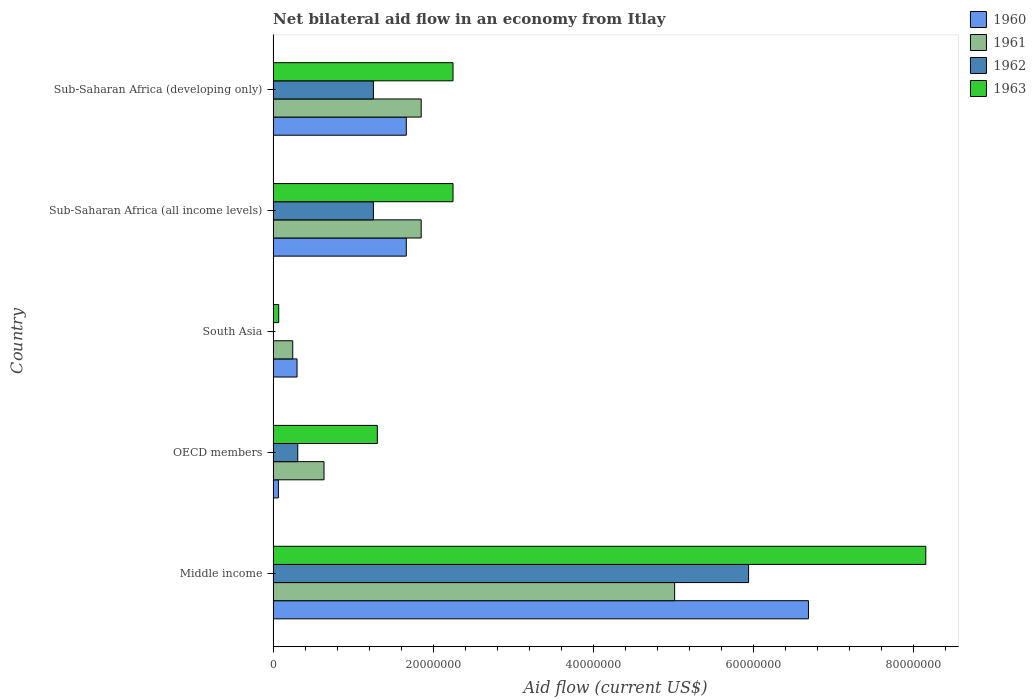How many groups of bars are there?
Your answer should be compact. 5. Are the number of bars per tick equal to the number of legend labels?
Offer a terse response. No. Are the number of bars on each tick of the Y-axis equal?
Your response must be concise. No. How many bars are there on the 5th tick from the top?
Give a very brief answer. 4. What is the label of the 1st group of bars from the top?
Keep it short and to the point. Sub-Saharan Africa (developing only). In how many cases, is the number of bars for a given country not equal to the number of legend labels?
Your response must be concise. 1. What is the net bilateral aid flow in 1961 in OECD members?
Provide a short and direct response. 6.36e+06. Across all countries, what is the maximum net bilateral aid flow in 1963?
Make the answer very short. 8.16e+07. Across all countries, what is the minimum net bilateral aid flow in 1961?
Keep it short and to the point. 2.45e+06. What is the total net bilateral aid flow in 1963 in the graph?
Give a very brief answer. 1.40e+08. What is the difference between the net bilateral aid flow in 1961 in OECD members and that in Sub-Saharan Africa (all income levels)?
Your answer should be compact. -1.21e+07. What is the difference between the net bilateral aid flow in 1961 in OECD members and the net bilateral aid flow in 1963 in Sub-Saharan Africa (developing only)?
Your answer should be compact. -1.61e+07. What is the average net bilateral aid flow in 1961 per country?
Offer a very short reply. 1.92e+07. What is the difference between the net bilateral aid flow in 1963 and net bilateral aid flow in 1960 in OECD members?
Your response must be concise. 1.24e+07. In how many countries, is the net bilateral aid flow in 1962 greater than 36000000 US$?
Give a very brief answer. 1. What is the ratio of the net bilateral aid flow in 1962 in Middle income to that in Sub-Saharan Africa (developing only)?
Provide a short and direct response. 4.74. What is the difference between the highest and the second highest net bilateral aid flow in 1963?
Your answer should be very brief. 5.91e+07. What is the difference between the highest and the lowest net bilateral aid flow in 1960?
Offer a very short reply. 6.62e+07. In how many countries, is the net bilateral aid flow in 1962 greater than the average net bilateral aid flow in 1962 taken over all countries?
Provide a succinct answer. 1. Is the sum of the net bilateral aid flow in 1961 in Middle income and OECD members greater than the maximum net bilateral aid flow in 1962 across all countries?
Make the answer very short. No. Is it the case that in every country, the sum of the net bilateral aid flow in 1962 and net bilateral aid flow in 1960 is greater than the sum of net bilateral aid flow in 1963 and net bilateral aid flow in 1961?
Offer a very short reply. No. How many countries are there in the graph?
Offer a very short reply. 5. Are the values on the major ticks of X-axis written in scientific E-notation?
Your answer should be compact. No. Does the graph contain grids?
Your answer should be very brief. No. What is the title of the graph?
Your answer should be very brief. Net bilateral aid flow in an economy from Itlay. What is the label or title of the X-axis?
Your response must be concise. Aid flow (current US$). What is the label or title of the Y-axis?
Ensure brevity in your answer.  Country. What is the Aid flow (current US$) in 1960 in Middle income?
Ensure brevity in your answer.  6.69e+07. What is the Aid flow (current US$) of 1961 in Middle income?
Your answer should be very brief. 5.02e+07. What is the Aid flow (current US$) of 1962 in Middle income?
Provide a succinct answer. 5.94e+07. What is the Aid flow (current US$) of 1963 in Middle income?
Provide a succinct answer. 8.16e+07. What is the Aid flow (current US$) in 1960 in OECD members?
Make the answer very short. 6.60e+05. What is the Aid flow (current US$) in 1961 in OECD members?
Ensure brevity in your answer.  6.36e+06. What is the Aid flow (current US$) in 1962 in OECD members?
Your response must be concise. 3.08e+06. What is the Aid flow (current US$) of 1963 in OECD members?
Offer a terse response. 1.30e+07. What is the Aid flow (current US$) of 1960 in South Asia?
Offer a terse response. 2.99e+06. What is the Aid flow (current US$) of 1961 in South Asia?
Provide a succinct answer. 2.45e+06. What is the Aid flow (current US$) of 1960 in Sub-Saharan Africa (all income levels)?
Offer a very short reply. 1.66e+07. What is the Aid flow (current US$) in 1961 in Sub-Saharan Africa (all income levels)?
Make the answer very short. 1.85e+07. What is the Aid flow (current US$) of 1962 in Sub-Saharan Africa (all income levels)?
Give a very brief answer. 1.25e+07. What is the Aid flow (current US$) of 1963 in Sub-Saharan Africa (all income levels)?
Your answer should be compact. 2.25e+07. What is the Aid flow (current US$) of 1960 in Sub-Saharan Africa (developing only)?
Keep it short and to the point. 1.66e+07. What is the Aid flow (current US$) in 1961 in Sub-Saharan Africa (developing only)?
Provide a succinct answer. 1.85e+07. What is the Aid flow (current US$) in 1962 in Sub-Saharan Africa (developing only)?
Make the answer very short. 1.25e+07. What is the Aid flow (current US$) of 1963 in Sub-Saharan Africa (developing only)?
Offer a very short reply. 2.25e+07. Across all countries, what is the maximum Aid flow (current US$) in 1960?
Provide a succinct answer. 6.69e+07. Across all countries, what is the maximum Aid flow (current US$) in 1961?
Offer a very short reply. 5.02e+07. Across all countries, what is the maximum Aid flow (current US$) in 1962?
Make the answer very short. 5.94e+07. Across all countries, what is the maximum Aid flow (current US$) in 1963?
Your answer should be compact. 8.16e+07. Across all countries, what is the minimum Aid flow (current US$) in 1960?
Provide a succinct answer. 6.60e+05. Across all countries, what is the minimum Aid flow (current US$) in 1961?
Keep it short and to the point. 2.45e+06. Across all countries, what is the minimum Aid flow (current US$) in 1963?
Keep it short and to the point. 7.00e+05. What is the total Aid flow (current US$) in 1960 in the graph?
Give a very brief answer. 1.04e+08. What is the total Aid flow (current US$) in 1961 in the graph?
Ensure brevity in your answer.  9.60e+07. What is the total Aid flow (current US$) of 1962 in the graph?
Your answer should be very brief. 8.76e+07. What is the total Aid flow (current US$) of 1963 in the graph?
Provide a short and direct response. 1.40e+08. What is the difference between the Aid flow (current US$) of 1960 in Middle income and that in OECD members?
Provide a short and direct response. 6.62e+07. What is the difference between the Aid flow (current US$) in 1961 in Middle income and that in OECD members?
Provide a short and direct response. 4.38e+07. What is the difference between the Aid flow (current US$) in 1962 in Middle income and that in OECD members?
Your answer should be very brief. 5.63e+07. What is the difference between the Aid flow (current US$) of 1963 in Middle income and that in OECD members?
Give a very brief answer. 6.85e+07. What is the difference between the Aid flow (current US$) in 1960 in Middle income and that in South Asia?
Provide a short and direct response. 6.39e+07. What is the difference between the Aid flow (current US$) in 1961 in Middle income and that in South Asia?
Ensure brevity in your answer.  4.77e+07. What is the difference between the Aid flow (current US$) of 1963 in Middle income and that in South Asia?
Your answer should be compact. 8.08e+07. What is the difference between the Aid flow (current US$) in 1960 in Middle income and that in Sub-Saharan Africa (all income levels)?
Your answer should be very brief. 5.02e+07. What is the difference between the Aid flow (current US$) of 1961 in Middle income and that in Sub-Saharan Africa (all income levels)?
Keep it short and to the point. 3.17e+07. What is the difference between the Aid flow (current US$) in 1962 in Middle income and that in Sub-Saharan Africa (all income levels)?
Offer a terse response. 4.69e+07. What is the difference between the Aid flow (current US$) of 1963 in Middle income and that in Sub-Saharan Africa (all income levels)?
Your answer should be very brief. 5.91e+07. What is the difference between the Aid flow (current US$) of 1960 in Middle income and that in Sub-Saharan Africa (developing only)?
Keep it short and to the point. 5.02e+07. What is the difference between the Aid flow (current US$) in 1961 in Middle income and that in Sub-Saharan Africa (developing only)?
Keep it short and to the point. 3.17e+07. What is the difference between the Aid flow (current US$) in 1962 in Middle income and that in Sub-Saharan Africa (developing only)?
Provide a short and direct response. 4.69e+07. What is the difference between the Aid flow (current US$) of 1963 in Middle income and that in Sub-Saharan Africa (developing only)?
Provide a short and direct response. 5.91e+07. What is the difference between the Aid flow (current US$) in 1960 in OECD members and that in South Asia?
Provide a succinct answer. -2.33e+06. What is the difference between the Aid flow (current US$) of 1961 in OECD members and that in South Asia?
Your answer should be compact. 3.91e+06. What is the difference between the Aid flow (current US$) of 1963 in OECD members and that in South Asia?
Your answer should be compact. 1.23e+07. What is the difference between the Aid flow (current US$) in 1960 in OECD members and that in Sub-Saharan Africa (all income levels)?
Your answer should be compact. -1.60e+07. What is the difference between the Aid flow (current US$) of 1961 in OECD members and that in Sub-Saharan Africa (all income levels)?
Your response must be concise. -1.21e+07. What is the difference between the Aid flow (current US$) in 1962 in OECD members and that in Sub-Saharan Africa (all income levels)?
Offer a very short reply. -9.45e+06. What is the difference between the Aid flow (current US$) of 1963 in OECD members and that in Sub-Saharan Africa (all income levels)?
Offer a very short reply. -9.46e+06. What is the difference between the Aid flow (current US$) in 1960 in OECD members and that in Sub-Saharan Africa (developing only)?
Provide a short and direct response. -1.60e+07. What is the difference between the Aid flow (current US$) in 1961 in OECD members and that in Sub-Saharan Africa (developing only)?
Your answer should be compact. -1.21e+07. What is the difference between the Aid flow (current US$) in 1962 in OECD members and that in Sub-Saharan Africa (developing only)?
Keep it short and to the point. -9.45e+06. What is the difference between the Aid flow (current US$) in 1963 in OECD members and that in Sub-Saharan Africa (developing only)?
Give a very brief answer. -9.46e+06. What is the difference between the Aid flow (current US$) of 1960 in South Asia and that in Sub-Saharan Africa (all income levels)?
Provide a succinct answer. -1.36e+07. What is the difference between the Aid flow (current US$) in 1961 in South Asia and that in Sub-Saharan Africa (all income levels)?
Your response must be concise. -1.60e+07. What is the difference between the Aid flow (current US$) in 1963 in South Asia and that in Sub-Saharan Africa (all income levels)?
Your answer should be compact. -2.18e+07. What is the difference between the Aid flow (current US$) in 1960 in South Asia and that in Sub-Saharan Africa (developing only)?
Your answer should be very brief. -1.36e+07. What is the difference between the Aid flow (current US$) in 1961 in South Asia and that in Sub-Saharan Africa (developing only)?
Provide a short and direct response. -1.60e+07. What is the difference between the Aid flow (current US$) in 1963 in South Asia and that in Sub-Saharan Africa (developing only)?
Make the answer very short. -2.18e+07. What is the difference between the Aid flow (current US$) in 1961 in Sub-Saharan Africa (all income levels) and that in Sub-Saharan Africa (developing only)?
Your answer should be compact. 0. What is the difference between the Aid flow (current US$) of 1962 in Sub-Saharan Africa (all income levels) and that in Sub-Saharan Africa (developing only)?
Provide a short and direct response. 0. What is the difference between the Aid flow (current US$) of 1960 in Middle income and the Aid flow (current US$) of 1961 in OECD members?
Make the answer very short. 6.05e+07. What is the difference between the Aid flow (current US$) of 1960 in Middle income and the Aid flow (current US$) of 1962 in OECD members?
Offer a terse response. 6.38e+07. What is the difference between the Aid flow (current US$) of 1960 in Middle income and the Aid flow (current US$) of 1963 in OECD members?
Provide a short and direct response. 5.39e+07. What is the difference between the Aid flow (current US$) of 1961 in Middle income and the Aid flow (current US$) of 1962 in OECD members?
Provide a short and direct response. 4.71e+07. What is the difference between the Aid flow (current US$) of 1961 in Middle income and the Aid flow (current US$) of 1963 in OECD members?
Keep it short and to the point. 3.72e+07. What is the difference between the Aid flow (current US$) of 1962 in Middle income and the Aid flow (current US$) of 1963 in OECD members?
Your answer should be very brief. 4.64e+07. What is the difference between the Aid flow (current US$) of 1960 in Middle income and the Aid flow (current US$) of 1961 in South Asia?
Ensure brevity in your answer.  6.44e+07. What is the difference between the Aid flow (current US$) in 1960 in Middle income and the Aid flow (current US$) in 1963 in South Asia?
Your answer should be very brief. 6.62e+07. What is the difference between the Aid flow (current US$) in 1961 in Middle income and the Aid flow (current US$) in 1963 in South Asia?
Give a very brief answer. 4.95e+07. What is the difference between the Aid flow (current US$) in 1962 in Middle income and the Aid flow (current US$) in 1963 in South Asia?
Your answer should be compact. 5.87e+07. What is the difference between the Aid flow (current US$) in 1960 in Middle income and the Aid flow (current US$) in 1961 in Sub-Saharan Africa (all income levels)?
Your answer should be compact. 4.84e+07. What is the difference between the Aid flow (current US$) in 1960 in Middle income and the Aid flow (current US$) in 1962 in Sub-Saharan Africa (all income levels)?
Your response must be concise. 5.44e+07. What is the difference between the Aid flow (current US$) in 1960 in Middle income and the Aid flow (current US$) in 1963 in Sub-Saharan Africa (all income levels)?
Offer a terse response. 4.44e+07. What is the difference between the Aid flow (current US$) of 1961 in Middle income and the Aid flow (current US$) of 1962 in Sub-Saharan Africa (all income levels)?
Provide a short and direct response. 3.76e+07. What is the difference between the Aid flow (current US$) in 1961 in Middle income and the Aid flow (current US$) in 1963 in Sub-Saharan Africa (all income levels)?
Your response must be concise. 2.77e+07. What is the difference between the Aid flow (current US$) of 1962 in Middle income and the Aid flow (current US$) of 1963 in Sub-Saharan Africa (all income levels)?
Provide a short and direct response. 3.69e+07. What is the difference between the Aid flow (current US$) in 1960 in Middle income and the Aid flow (current US$) in 1961 in Sub-Saharan Africa (developing only)?
Offer a very short reply. 4.84e+07. What is the difference between the Aid flow (current US$) of 1960 in Middle income and the Aid flow (current US$) of 1962 in Sub-Saharan Africa (developing only)?
Make the answer very short. 5.44e+07. What is the difference between the Aid flow (current US$) in 1960 in Middle income and the Aid flow (current US$) in 1963 in Sub-Saharan Africa (developing only)?
Give a very brief answer. 4.44e+07. What is the difference between the Aid flow (current US$) of 1961 in Middle income and the Aid flow (current US$) of 1962 in Sub-Saharan Africa (developing only)?
Give a very brief answer. 3.76e+07. What is the difference between the Aid flow (current US$) in 1961 in Middle income and the Aid flow (current US$) in 1963 in Sub-Saharan Africa (developing only)?
Provide a short and direct response. 2.77e+07. What is the difference between the Aid flow (current US$) of 1962 in Middle income and the Aid flow (current US$) of 1963 in Sub-Saharan Africa (developing only)?
Keep it short and to the point. 3.69e+07. What is the difference between the Aid flow (current US$) in 1960 in OECD members and the Aid flow (current US$) in 1961 in South Asia?
Provide a succinct answer. -1.79e+06. What is the difference between the Aid flow (current US$) in 1961 in OECD members and the Aid flow (current US$) in 1963 in South Asia?
Keep it short and to the point. 5.66e+06. What is the difference between the Aid flow (current US$) in 1962 in OECD members and the Aid flow (current US$) in 1963 in South Asia?
Provide a short and direct response. 2.38e+06. What is the difference between the Aid flow (current US$) in 1960 in OECD members and the Aid flow (current US$) in 1961 in Sub-Saharan Africa (all income levels)?
Give a very brief answer. -1.78e+07. What is the difference between the Aid flow (current US$) in 1960 in OECD members and the Aid flow (current US$) in 1962 in Sub-Saharan Africa (all income levels)?
Offer a terse response. -1.19e+07. What is the difference between the Aid flow (current US$) in 1960 in OECD members and the Aid flow (current US$) in 1963 in Sub-Saharan Africa (all income levels)?
Your response must be concise. -2.18e+07. What is the difference between the Aid flow (current US$) of 1961 in OECD members and the Aid flow (current US$) of 1962 in Sub-Saharan Africa (all income levels)?
Your answer should be compact. -6.17e+06. What is the difference between the Aid flow (current US$) in 1961 in OECD members and the Aid flow (current US$) in 1963 in Sub-Saharan Africa (all income levels)?
Your answer should be very brief. -1.61e+07. What is the difference between the Aid flow (current US$) of 1962 in OECD members and the Aid flow (current US$) of 1963 in Sub-Saharan Africa (all income levels)?
Keep it short and to the point. -1.94e+07. What is the difference between the Aid flow (current US$) of 1960 in OECD members and the Aid flow (current US$) of 1961 in Sub-Saharan Africa (developing only)?
Ensure brevity in your answer.  -1.78e+07. What is the difference between the Aid flow (current US$) of 1960 in OECD members and the Aid flow (current US$) of 1962 in Sub-Saharan Africa (developing only)?
Give a very brief answer. -1.19e+07. What is the difference between the Aid flow (current US$) of 1960 in OECD members and the Aid flow (current US$) of 1963 in Sub-Saharan Africa (developing only)?
Ensure brevity in your answer.  -2.18e+07. What is the difference between the Aid flow (current US$) of 1961 in OECD members and the Aid flow (current US$) of 1962 in Sub-Saharan Africa (developing only)?
Make the answer very short. -6.17e+06. What is the difference between the Aid flow (current US$) of 1961 in OECD members and the Aid flow (current US$) of 1963 in Sub-Saharan Africa (developing only)?
Make the answer very short. -1.61e+07. What is the difference between the Aid flow (current US$) in 1962 in OECD members and the Aid flow (current US$) in 1963 in Sub-Saharan Africa (developing only)?
Offer a very short reply. -1.94e+07. What is the difference between the Aid flow (current US$) of 1960 in South Asia and the Aid flow (current US$) of 1961 in Sub-Saharan Africa (all income levels)?
Keep it short and to the point. -1.55e+07. What is the difference between the Aid flow (current US$) of 1960 in South Asia and the Aid flow (current US$) of 1962 in Sub-Saharan Africa (all income levels)?
Your answer should be compact. -9.54e+06. What is the difference between the Aid flow (current US$) in 1960 in South Asia and the Aid flow (current US$) in 1963 in Sub-Saharan Africa (all income levels)?
Your answer should be very brief. -1.95e+07. What is the difference between the Aid flow (current US$) of 1961 in South Asia and the Aid flow (current US$) of 1962 in Sub-Saharan Africa (all income levels)?
Offer a terse response. -1.01e+07. What is the difference between the Aid flow (current US$) in 1961 in South Asia and the Aid flow (current US$) in 1963 in Sub-Saharan Africa (all income levels)?
Keep it short and to the point. -2.00e+07. What is the difference between the Aid flow (current US$) in 1960 in South Asia and the Aid flow (current US$) in 1961 in Sub-Saharan Africa (developing only)?
Offer a terse response. -1.55e+07. What is the difference between the Aid flow (current US$) in 1960 in South Asia and the Aid flow (current US$) in 1962 in Sub-Saharan Africa (developing only)?
Offer a very short reply. -9.54e+06. What is the difference between the Aid flow (current US$) in 1960 in South Asia and the Aid flow (current US$) in 1963 in Sub-Saharan Africa (developing only)?
Provide a succinct answer. -1.95e+07. What is the difference between the Aid flow (current US$) in 1961 in South Asia and the Aid flow (current US$) in 1962 in Sub-Saharan Africa (developing only)?
Ensure brevity in your answer.  -1.01e+07. What is the difference between the Aid flow (current US$) in 1961 in South Asia and the Aid flow (current US$) in 1963 in Sub-Saharan Africa (developing only)?
Your answer should be very brief. -2.00e+07. What is the difference between the Aid flow (current US$) of 1960 in Sub-Saharan Africa (all income levels) and the Aid flow (current US$) of 1961 in Sub-Saharan Africa (developing only)?
Your response must be concise. -1.86e+06. What is the difference between the Aid flow (current US$) in 1960 in Sub-Saharan Africa (all income levels) and the Aid flow (current US$) in 1962 in Sub-Saharan Africa (developing only)?
Offer a very short reply. 4.11e+06. What is the difference between the Aid flow (current US$) in 1960 in Sub-Saharan Africa (all income levels) and the Aid flow (current US$) in 1963 in Sub-Saharan Africa (developing only)?
Offer a terse response. -5.84e+06. What is the difference between the Aid flow (current US$) in 1961 in Sub-Saharan Africa (all income levels) and the Aid flow (current US$) in 1962 in Sub-Saharan Africa (developing only)?
Ensure brevity in your answer.  5.97e+06. What is the difference between the Aid flow (current US$) in 1961 in Sub-Saharan Africa (all income levels) and the Aid flow (current US$) in 1963 in Sub-Saharan Africa (developing only)?
Provide a short and direct response. -3.98e+06. What is the difference between the Aid flow (current US$) in 1962 in Sub-Saharan Africa (all income levels) and the Aid flow (current US$) in 1963 in Sub-Saharan Africa (developing only)?
Keep it short and to the point. -9.95e+06. What is the average Aid flow (current US$) of 1960 per country?
Make the answer very short. 2.08e+07. What is the average Aid flow (current US$) in 1961 per country?
Provide a short and direct response. 1.92e+07. What is the average Aid flow (current US$) in 1962 per country?
Give a very brief answer. 1.75e+07. What is the average Aid flow (current US$) of 1963 per country?
Offer a terse response. 2.80e+07. What is the difference between the Aid flow (current US$) in 1960 and Aid flow (current US$) in 1961 in Middle income?
Offer a very short reply. 1.67e+07. What is the difference between the Aid flow (current US$) in 1960 and Aid flow (current US$) in 1962 in Middle income?
Make the answer very short. 7.48e+06. What is the difference between the Aid flow (current US$) of 1960 and Aid flow (current US$) of 1963 in Middle income?
Provide a succinct answer. -1.47e+07. What is the difference between the Aid flow (current US$) of 1961 and Aid flow (current US$) of 1962 in Middle income?
Make the answer very short. -9.24e+06. What is the difference between the Aid flow (current US$) in 1961 and Aid flow (current US$) in 1963 in Middle income?
Offer a very short reply. -3.14e+07. What is the difference between the Aid flow (current US$) of 1962 and Aid flow (current US$) of 1963 in Middle income?
Your response must be concise. -2.21e+07. What is the difference between the Aid flow (current US$) of 1960 and Aid flow (current US$) of 1961 in OECD members?
Your response must be concise. -5.70e+06. What is the difference between the Aid flow (current US$) of 1960 and Aid flow (current US$) of 1962 in OECD members?
Give a very brief answer. -2.42e+06. What is the difference between the Aid flow (current US$) of 1960 and Aid flow (current US$) of 1963 in OECD members?
Your answer should be very brief. -1.24e+07. What is the difference between the Aid flow (current US$) of 1961 and Aid flow (current US$) of 1962 in OECD members?
Ensure brevity in your answer.  3.28e+06. What is the difference between the Aid flow (current US$) of 1961 and Aid flow (current US$) of 1963 in OECD members?
Keep it short and to the point. -6.66e+06. What is the difference between the Aid flow (current US$) in 1962 and Aid flow (current US$) in 1963 in OECD members?
Your answer should be very brief. -9.94e+06. What is the difference between the Aid flow (current US$) of 1960 and Aid flow (current US$) of 1961 in South Asia?
Your answer should be very brief. 5.40e+05. What is the difference between the Aid flow (current US$) in 1960 and Aid flow (current US$) in 1963 in South Asia?
Offer a very short reply. 2.29e+06. What is the difference between the Aid flow (current US$) in 1961 and Aid flow (current US$) in 1963 in South Asia?
Provide a short and direct response. 1.75e+06. What is the difference between the Aid flow (current US$) of 1960 and Aid flow (current US$) of 1961 in Sub-Saharan Africa (all income levels)?
Offer a very short reply. -1.86e+06. What is the difference between the Aid flow (current US$) of 1960 and Aid flow (current US$) of 1962 in Sub-Saharan Africa (all income levels)?
Offer a very short reply. 4.11e+06. What is the difference between the Aid flow (current US$) of 1960 and Aid flow (current US$) of 1963 in Sub-Saharan Africa (all income levels)?
Offer a terse response. -5.84e+06. What is the difference between the Aid flow (current US$) in 1961 and Aid flow (current US$) in 1962 in Sub-Saharan Africa (all income levels)?
Provide a short and direct response. 5.97e+06. What is the difference between the Aid flow (current US$) in 1961 and Aid flow (current US$) in 1963 in Sub-Saharan Africa (all income levels)?
Your answer should be compact. -3.98e+06. What is the difference between the Aid flow (current US$) of 1962 and Aid flow (current US$) of 1963 in Sub-Saharan Africa (all income levels)?
Give a very brief answer. -9.95e+06. What is the difference between the Aid flow (current US$) of 1960 and Aid flow (current US$) of 1961 in Sub-Saharan Africa (developing only)?
Make the answer very short. -1.86e+06. What is the difference between the Aid flow (current US$) in 1960 and Aid flow (current US$) in 1962 in Sub-Saharan Africa (developing only)?
Your answer should be compact. 4.11e+06. What is the difference between the Aid flow (current US$) in 1960 and Aid flow (current US$) in 1963 in Sub-Saharan Africa (developing only)?
Ensure brevity in your answer.  -5.84e+06. What is the difference between the Aid flow (current US$) of 1961 and Aid flow (current US$) of 1962 in Sub-Saharan Africa (developing only)?
Ensure brevity in your answer.  5.97e+06. What is the difference between the Aid flow (current US$) in 1961 and Aid flow (current US$) in 1963 in Sub-Saharan Africa (developing only)?
Offer a terse response. -3.98e+06. What is the difference between the Aid flow (current US$) of 1962 and Aid flow (current US$) of 1963 in Sub-Saharan Africa (developing only)?
Provide a succinct answer. -9.95e+06. What is the ratio of the Aid flow (current US$) in 1960 in Middle income to that in OECD members?
Make the answer very short. 101.35. What is the ratio of the Aid flow (current US$) in 1961 in Middle income to that in OECD members?
Offer a terse response. 7.89. What is the ratio of the Aid flow (current US$) of 1962 in Middle income to that in OECD members?
Offer a very short reply. 19.29. What is the ratio of the Aid flow (current US$) of 1963 in Middle income to that in OECD members?
Ensure brevity in your answer.  6.26. What is the ratio of the Aid flow (current US$) of 1960 in Middle income to that in South Asia?
Keep it short and to the point. 22.37. What is the ratio of the Aid flow (current US$) in 1961 in Middle income to that in South Asia?
Your answer should be very brief. 20.48. What is the ratio of the Aid flow (current US$) of 1963 in Middle income to that in South Asia?
Keep it short and to the point. 116.5. What is the ratio of the Aid flow (current US$) of 1960 in Middle income to that in Sub-Saharan Africa (all income levels)?
Ensure brevity in your answer.  4.02. What is the ratio of the Aid flow (current US$) in 1961 in Middle income to that in Sub-Saharan Africa (all income levels)?
Your answer should be compact. 2.71. What is the ratio of the Aid flow (current US$) of 1962 in Middle income to that in Sub-Saharan Africa (all income levels)?
Give a very brief answer. 4.74. What is the ratio of the Aid flow (current US$) in 1963 in Middle income to that in Sub-Saharan Africa (all income levels)?
Your response must be concise. 3.63. What is the ratio of the Aid flow (current US$) in 1960 in Middle income to that in Sub-Saharan Africa (developing only)?
Offer a terse response. 4.02. What is the ratio of the Aid flow (current US$) in 1961 in Middle income to that in Sub-Saharan Africa (developing only)?
Offer a very short reply. 2.71. What is the ratio of the Aid flow (current US$) of 1962 in Middle income to that in Sub-Saharan Africa (developing only)?
Your answer should be very brief. 4.74. What is the ratio of the Aid flow (current US$) in 1963 in Middle income to that in Sub-Saharan Africa (developing only)?
Provide a short and direct response. 3.63. What is the ratio of the Aid flow (current US$) of 1960 in OECD members to that in South Asia?
Provide a short and direct response. 0.22. What is the ratio of the Aid flow (current US$) of 1961 in OECD members to that in South Asia?
Offer a terse response. 2.6. What is the ratio of the Aid flow (current US$) in 1963 in OECD members to that in South Asia?
Give a very brief answer. 18.6. What is the ratio of the Aid flow (current US$) of 1960 in OECD members to that in Sub-Saharan Africa (all income levels)?
Make the answer very short. 0.04. What is the ratio of the Aid flow (current US$) in 1961 in OECD members to that in Sub-Saharan Africa (all income levels)?
Provide a succinct answer. 0.34. What is the ratio of the Aid flow (current US$) of 1962 in OECD members to that in Sub-Saharan Africa (all income levels)?
Make the answer very short. 0.25. What is the ratio of the Aid flow (current US$) of 1963 in OECD members to that in Sub-Saharan Africa (all income levels)?
Your answer should be compact. 0.58. What is the ratio of the Aid flow (current US$) in 1960 in OECD members to that in Sub-Saharan Africa (developing only)?
Provide a short and direct response. 0.04. What is the ratio of the Aid flow (current US$) of 1961 in OECD members to that in Sub-Saharan Africa (developing only)?
Your answer should be very brief. 0.34. What is the ratio of the Aid flow (current US$) in 1962 in OECD members to that in Sub-Saharan Africa (developing only)?
Provide a succinct answer. 0.25. What is the ratio of the Aid flow (current US$) of 1963 in OECD members to that in Sub-Saharan Africa (developing only)?
Your answer should be very brief. 0.58. What is the ratio of the Aid flow (current US$) of 1960 in South Asia to that in Sub-Saharan Africa (all income levels)?
Keep it short and to the point. 0.18. What is the ratio of the Aid flow (current US$) of 1961 in South Asia to that in Sub-Saharan Africa (all income levels)?
Make the answer very short. 0.13. What is the ratio of the Aid flow (current US$) in 1963 in South Asia to that in Sub-Saharan Africa (all income levels)?
Offer a terse response. 0.03. What is the ratio of the Aid flow (current US$) in 1960 in South Asia to that in Sub-Saharan Africa (developing only)?
Provide a short and direct response. 0.18. What is the ratio of the Aid flow (current US$) in 1961 in South Asia to that in Sub-Saharan Africa (developing only)?
Keep it short and to the point. 0.13. What is the ratio of the Aid flow (current US$) in 1963 in South Asia to that in Sub-Saharan Africa (developing only)?
Offer a very short reply. 0.03. What is the ratio of the Aid flow (current US$) of 1960 in Sub-Saharan Africa (all income levels) to that in Sub-Saharan Africa (developing only)?
Ensure brevity in your answer.  1. What is the ratio of the Aid flow (current US$) of 1961 in Sub-Saharan Africa (all income levels) to that in Sub-Saharan Africa (developing only)?
Your answer should be very brief. 1. What is the difference between the highest and the second highest Aid flow (current US$) in 1960?
Give a very brief answer. 5.02e+07. What is the difference between the highest and the second highest Aid flow (current US$) in 1961?
Keep it short and to the point. 3.17e+07. What is the difference between the highest and the second highest Aid flow (current US$) in 1962?
Provide a short and direct response. 4.69e+07. What is the difference between the highest and the second highest Aid flow (current US$) of 1963?
Provide a succinct answer. 5.91e+07. What is the difference between the highest and the lowest Aid flow (current US$) in 1960?
Make the answer very short. 6.62e+07. What is the difference between the highest and the lowest Aid flow (current US$) of 1961?
Provide a succinct answer. 4.77e+07. What is the difference between the highest and the lowest Aid flow (current US$) of 1962?
Your answer should be compact. 5.94e+07. What is the difference between the highest and the lowest Aid flow (current US$) in 1963?
Provide a short and direct response. 8.08e+07. 